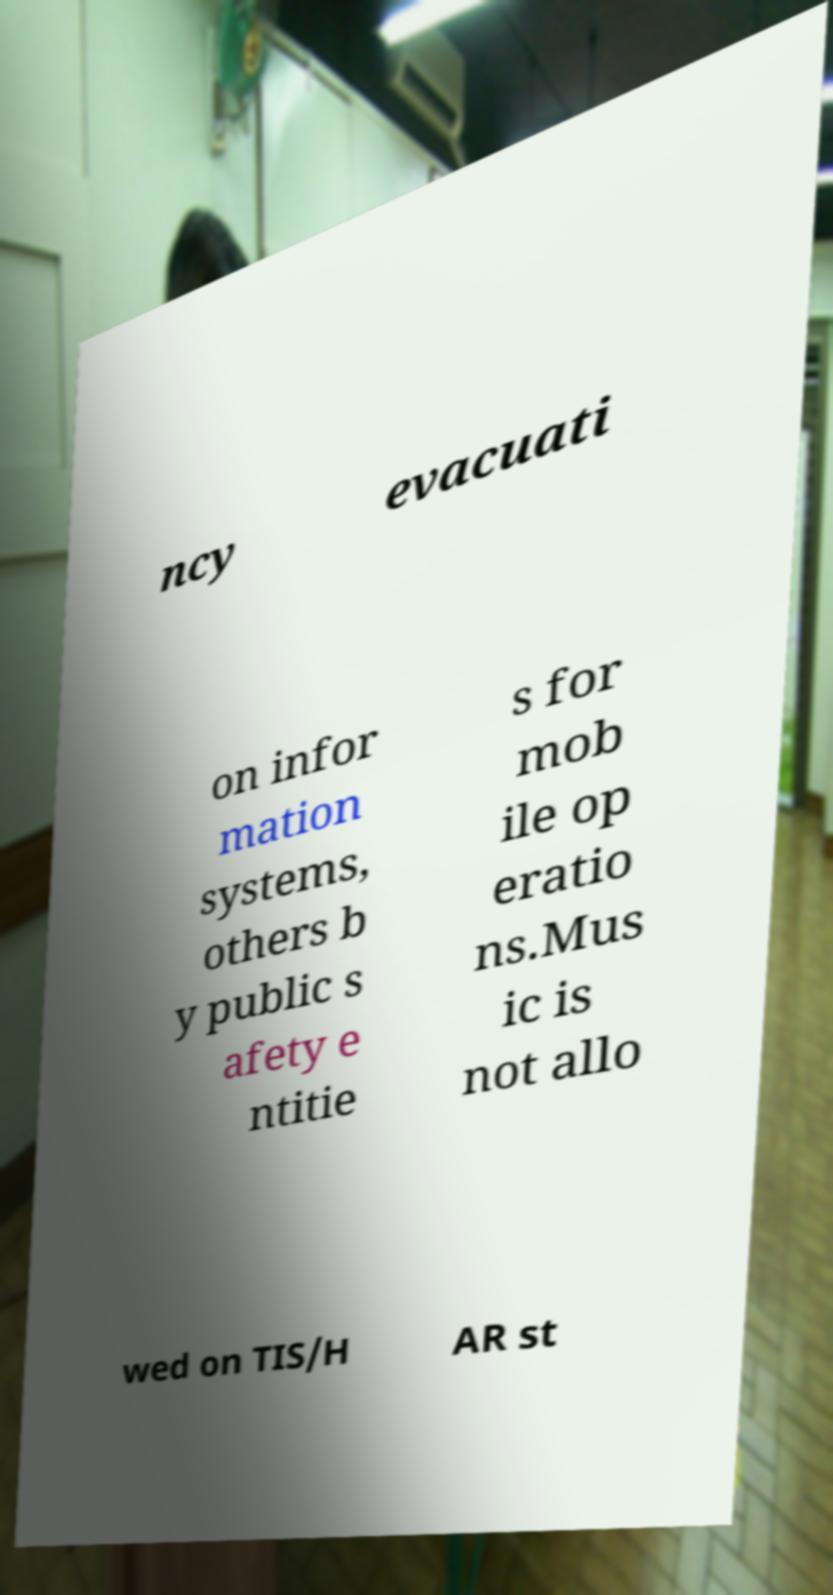There's text embedded in this image that I need extracted. Can you transcribe it verbatim? ncy evacuati on infor mation systems, others b y public s afety e ntitie s for mob ile op eratio ns.Mus ic is not allo wed on TIS/H AR st 